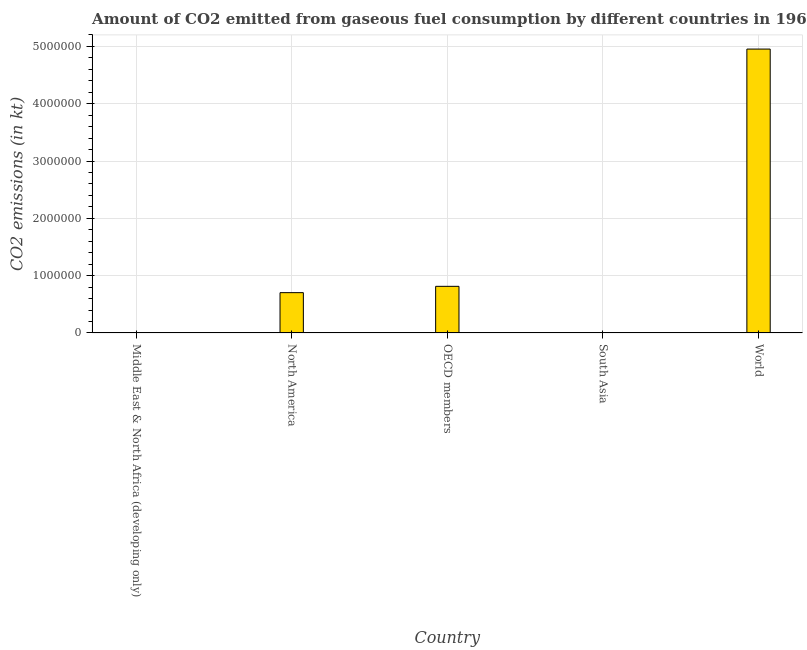Does the graph contain grids?
Keep it short and to the point. Yes. What is the title of the graph?
Your answer should be compact. Amount of CO2 emitted from gaseous fuel consumption by different countries in 1962. What is the label or title of the Y-axis?
Offer a very short reply. CO2 emissions (in kt). What is the co2 emissions from gaseous fuel consumption in Middle East & North Africa (developing only)?
Offer a very short reply. 4564.99. Across all countries, what is the maximum co2 emissions from gaseous fuel consumption?
Offer a terse response. 4.95e+06. Across all countries, what is the minimum co2 emissions from gaseous fuel consumption?
Keep it short and to the point. 2006.63. What is the sum of the co2 emissions from gaseous fuel consumption?
Ensure brevity in your answer.  6.48e+06. What is the difference between the co2 emissions from gaseous fuel consumption in South Asia and World?
Ensure brevity in your answer.  -4.95e+06. What is the average co2 emissions from gaseous fuel consumption per country?
Your answer should be very brief. 1.30e+06. What is the median co2 emissions from gaseous fuel consumption?
Your answer should be very brief. 7.03e+05. In how many countries, is the co2 emissions from gaseous fuel consumption greater than 800000 kt?
Give a very brief answer. 2. What is the ratio of the co2 emissions from gaseous fuel consumption in Middle East & North Africa (developing only) to that in North America?
Give a very brief answer. 0.01. Is the co2 emissions from gaseous fuel consumption in OECD members less than that in World?
Your response must be concise. Yes. What is the difference between the highest and the second highest co2 emissions from gaseous fuel consumption?
Offer a very short reply. 4.14e+06. Is the sum of the co2 emissions from gaseous fuel consumption in OECD members and World greater than the maximum co2 emissions from gaseous fuel consumption across all countries?
Offer a terse response. Yes. What is the difference between the highest and the lowest co2 emissions from gaseous fuel consumption?
Make the answer very short. 4.95e+06. How many bars are there?
Make the answer very short. 5. How many countries are there in the graph?
Make the answer very short. 5. What is the difference between two consecutive major ticks on the Y-axis?
Provide a succinct answer. 1.00e+06. Are the values on the major ticks of Y-axis written in scientific E-notation?
Provide a succinct answer. No. What is the CO2 emissions (in kt) in Middle East & North Africa (developing only)?
Provide a short and direct response. 4564.99. What is the CO2 emissions (in kt) of North America?
Your answer should be very brief. 7.03e+05. What is the CO2 emissions (in kt) in OECD members?
Offer a very short reply. 8.13e+05. What is the CO2 emissions (in kt) in South Asia?
Your response must be concise. 2006.63. What is the CO2 emissions (in kt) in World?
Your answer should be compact. 4.95e+06. What is the difference between the CO2 emissions (in kt) in Middle East & North Africa (developing only) and North America?
Ensure brevity in your answer.  -6.99e+05. What is the difference between the CO2 emissions (in kt) in Middle East & North Africa (developing only) and OECD members?
Provide a succinct answer. -8.09e+05. What is the difference between the CO2 emissions (in kt) in Middle East & North Africa (developing only) and South Asia?
Your response must be concise. 2558.35. What is the difference between the CO2 emissions (in kt) in Middle East & North Africa (developing only) and World?
Your response must be concise. -4.95e+06. What is the difference between the CO2 emissions (in kt) in North America and OECD members?
Provide a short and direct response. -1.10e+05. What is the difference between the CO2 emissions (in kt) in North America and South Asia?
Your answer should be very brief. 7.01e+05. What is the difference between the CO2 emissions (in kt) in North America and World?
Offer a very short reply. -4.25e+06. What is the difference between the CO2 emissions (in kt) in OECD members and South Asia?
Provide a succinct answer. 8.11e+05. What is the difference between the CO2 emissions (in kt) in OECD members and World?
Keep it short and to the point. -4.14e+06. What is the difference between the CO2 emissions (in kt) in South Asia and World?
Your answer should be compact. -4.95e+06. What is the ratio of the CO2 emissions (in kt) in Middle East & North Africa (developing only) to that in North America?
Keep it short and to the point. 0.01. What is the ratio of the CO2 emissions (in kt) in Middle East & North Africa (developing only) to that in OECD members?
Your response must be concise. 0.01. What is the ratio of the CO2 emissions (in kt) in Middle East & North Africa (developing only) to that in South Asia?
Your response must be concise. 2.27. What is the ratio of the CO2 emissions (in kt) in North America to that in OECD members?
Offer a terse response. 0.86. What is the ratio of the CO2 emissions (in kt) in North America to that in South Asia?
Keep it short and to the point. 350.44. What is the ratio of the CO2 emissions (in kt) in North America to that in World?
Your answer should be very brief. 0.14. What is the ratio of the CO2 emissions (in kt) in OECD members to that in South Asia?
Your response must be concise. 405.26. What is the ratio of the CO2 emissions (in kt) in OECD members to that in World?
Offer a terse response. 0.16. 